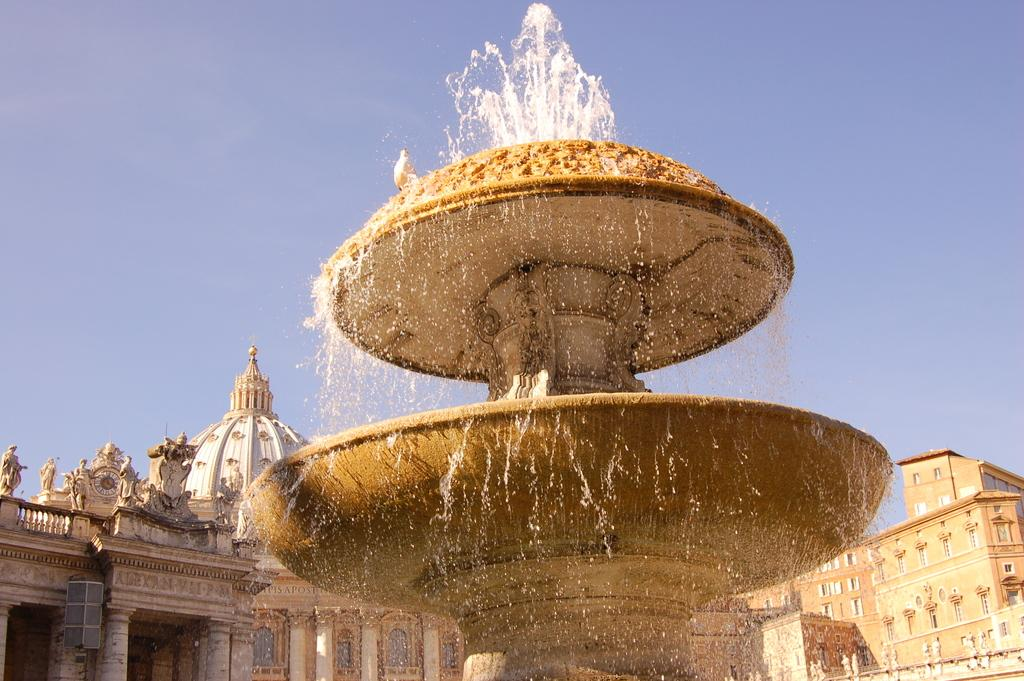What is the main subject in the image? There is a fountain in the image. What can be seen in the background of the image? There is a monument and the sky visible in the background of the image. What type of rice is being cooked in the image? There is no rice present in the image; it features a fountain and a monument in the background. What type of root vegetable is growing near the fountain in the image? There is no root vegetable present in the image; it features a fountain and a monument in the background. 